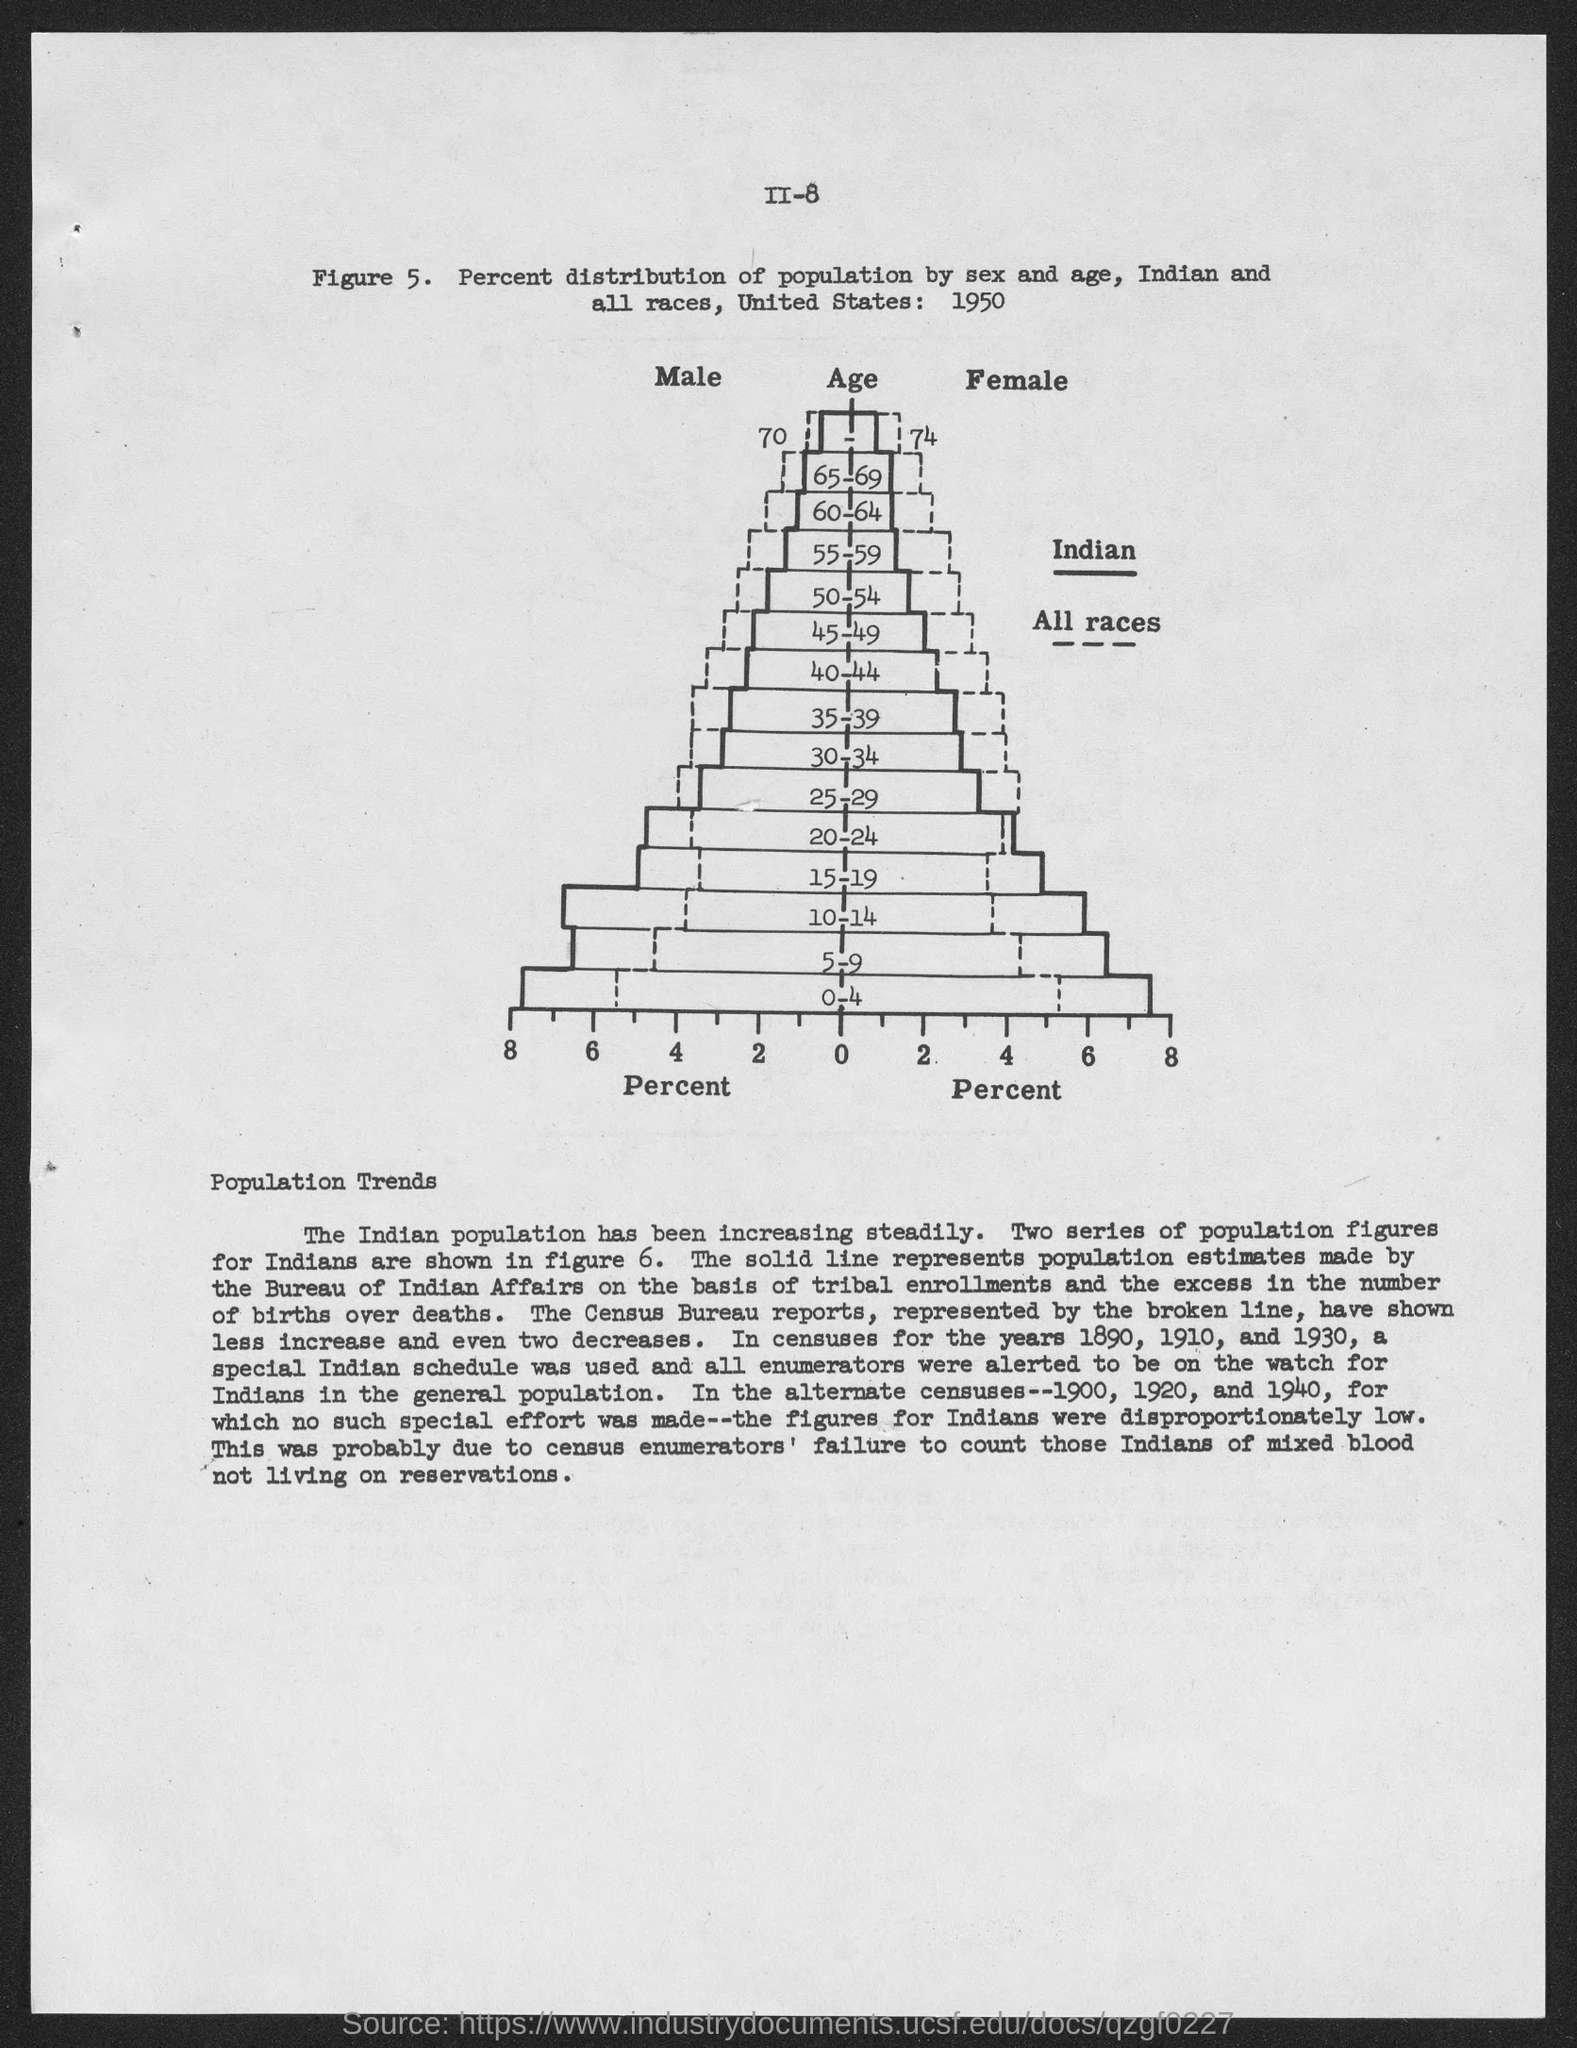Point out several critical features in this image. The age is represented on the y-axis of the graph. The percent distribution of population by sex and age has been carried out among various populations, including Indian and all races. The United States conducted a study of population distribution in the year 1950, which involved determining the percentage of the population living in various regions and cities. The explanation of Figure 5 is given the subheading "Population Trends. The X-axis of the graph represents the percentage of students who have completed high school, with the highest percentage being 100% and the lowest percentage being 0%. 